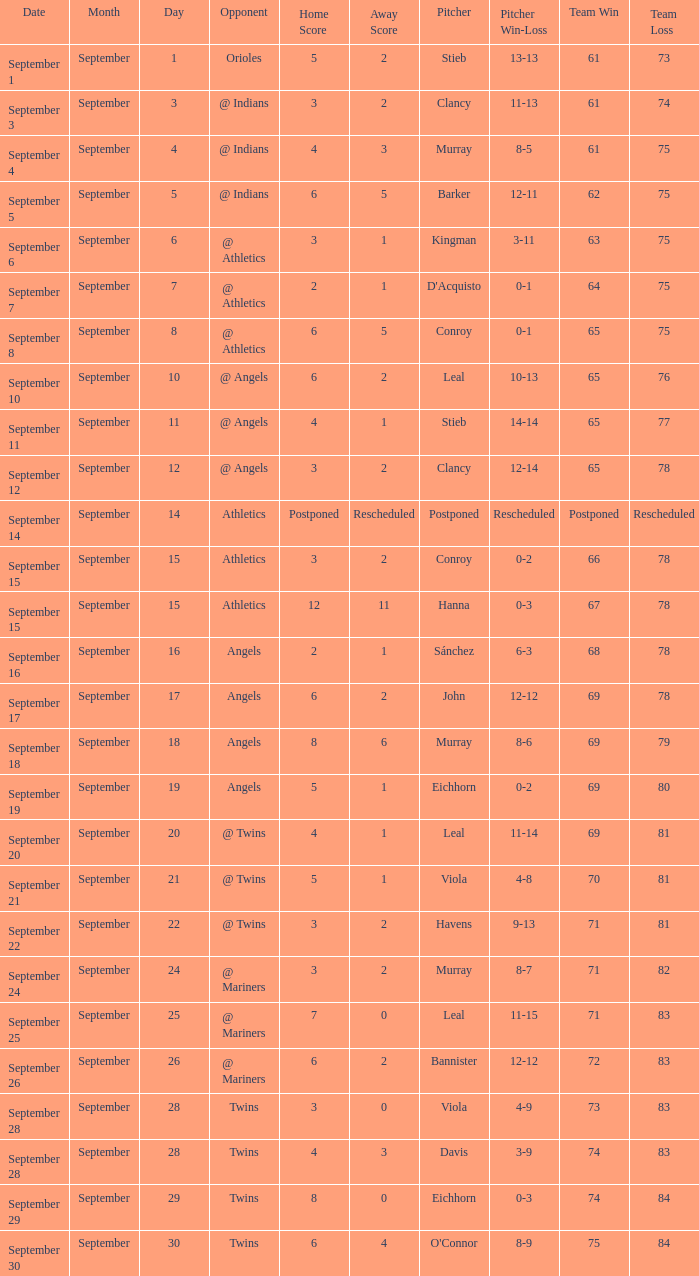What was the score on september 11? 4 - 1. 